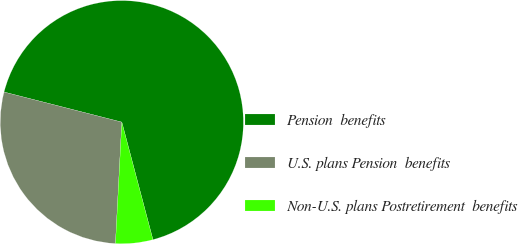<chart> <loc_0><loc_0><loc_500><loc_500><pie_chart><fcel>Pension  benefits<fcel>U.S. plans Pension  benefits<fcel>Non-U.S. plans Postretirement  benefits<nl><fcel>66.91%<fcel>28.15%<fcel>4.95%<nl></chart> 